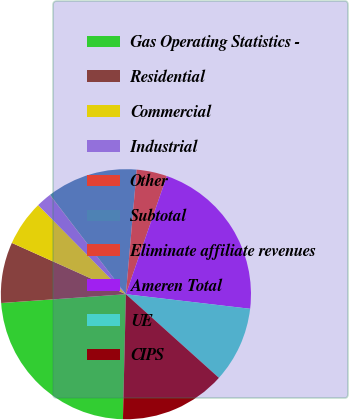Convert chart. <chart><loc_0><loc_0><loc_500><loc_500><pie_chart><fcel>Gas Operating Statistics -<fcel>Residential<fcel>Commercial<fcel>Industrial<fcel>Other<fcel>Subtotal<fcel>Eliminate affiliate revenues<fcel>Ameren Total<fcel>UE<fcel>CIPS<nl><fcel>23.5%<fcel>7.85%<fcel>5.89%<fcel>1.98%<fcel>0.02%<fcel>11.76%<fcel>3.93%<fcel>21.55%<fcel>9.8%<fcel>13.72%<nl></chart> 